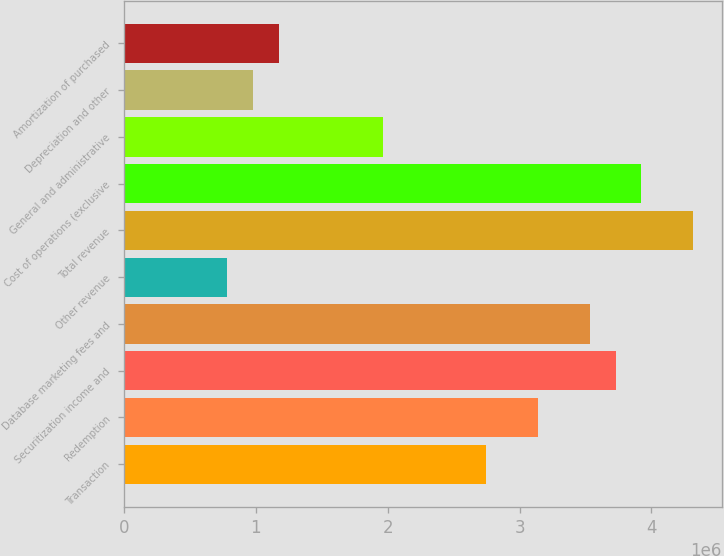Convert chart to OTSL. <chart><loc_0><loc_0><loc_500><loc_500><bar_chart><fcel>Transaction<fcel>Redemption<fcel>Securitization income and<fcel>Database marketing fees and<fcel>Other revenue<fcel>Total revenue<fcel>Cost of operations (exclusive<fcel>General and administrative<fcel>Depreciation and other<fcel>Amortization of purchased<nl><fcel>2.74702e+06<fcel>3.13945e+06<fcel>3.7281e+06<fcel>3.53189e+06<fcel>784864<fcel>4.31675e+06<fcel>3.92432e+06<fcel>1.96216e+06<fcel>981080<fcel>1.1773e+06<nl></chart> 